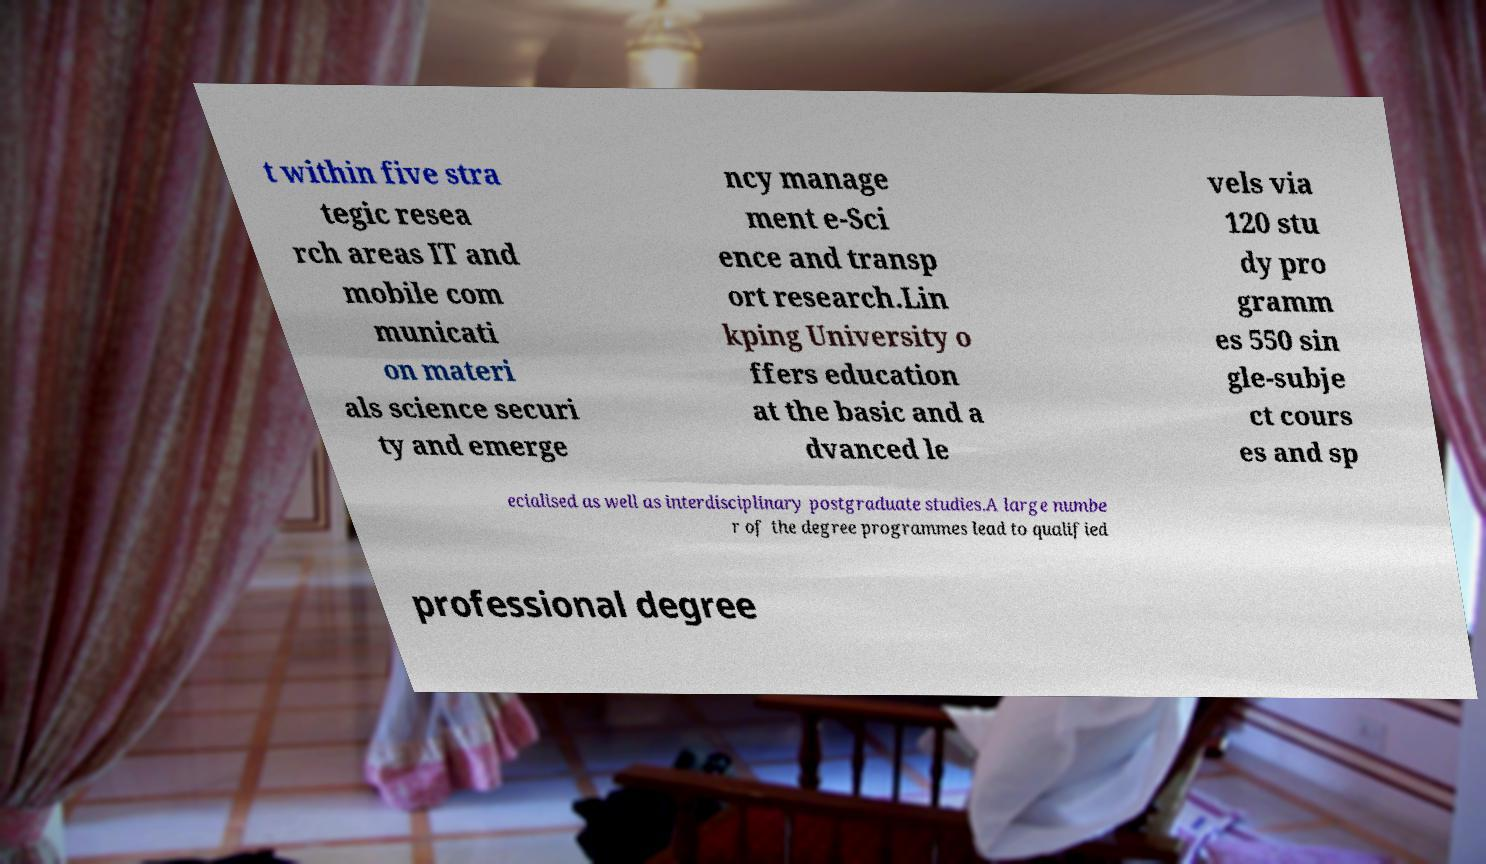For documentation purposes, I need the text within this image transcribed. Could you provide that? t within five stra tegic resea rch areas IT and mobile com municati on materi als science securi ty and emerge ncy manage ment e-Sci ence and transp ort research.Lin kping University o ffers education at the basic and a dvanced le vels via 120 stu dy pro gramm es 550 sin gle-subje ct cours es and sp ecialised as well as interdisciplinary postgraduate studies.A large numbe r of the degree programmes lead to qualified professional degree 